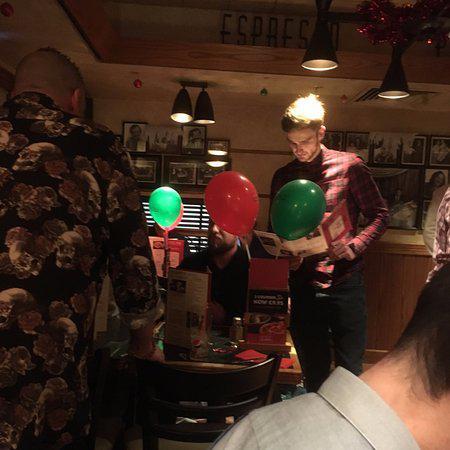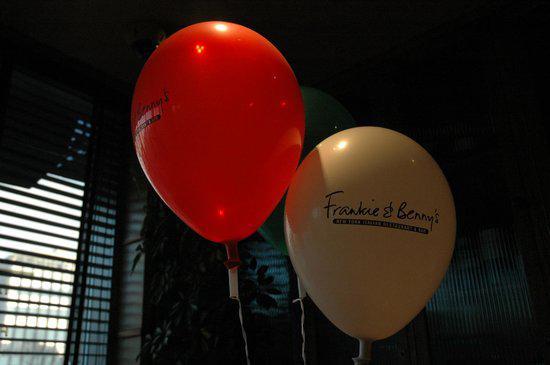The first image is the image on the left, the second image is the image on the right. For the images displayed, is the sentence "The left and right image contains no more than six balloons." factually correct? Answer yes or no. Yes. The first image is the image on the left, the second image is the image on the right. For the images shown, is this caption "The left image features no more than four balloons in a restaurant scene, including red and green balloons, and the right image includes a red balloon to the left of a white balloon." true? Answer yes or no. Yes. 